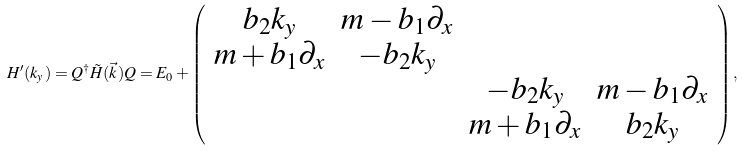Convert formula to latex. <formula><loc_0><loc_0><loc_500><loc_500>H ^ { \prime } ( k _ { y } ) = Q ^ { \dagger } \tilde { H } ( \vec { k } ) Q = E _ { 0 } + \left ( \begin{array} { c c c c } b _ { 2 } k _ { y } & m - b _ { 1 } \partial _ { x } & & \\ m + b _ { 1 } \partial _ { x } & - b _ { 2 } k _ { y } & & \\ & & - b _ { 2 } k _ { y } & m - b _ { 1 } \partial _ { x } \\ & & m + b _ { 1 } \partial _ { x } & b _ { 2 } k _ { y } \end{array} \right ) ,</formula> 